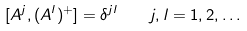Convert formula to latex. <formula><loc_0><loc_0><loc_500><loc_500>[ A ^ { j } , ( A ^ { l } ) ^ { + } ] = \delta ^ { j l } \quad j , l = 1 , 2 , \dots</formula> 